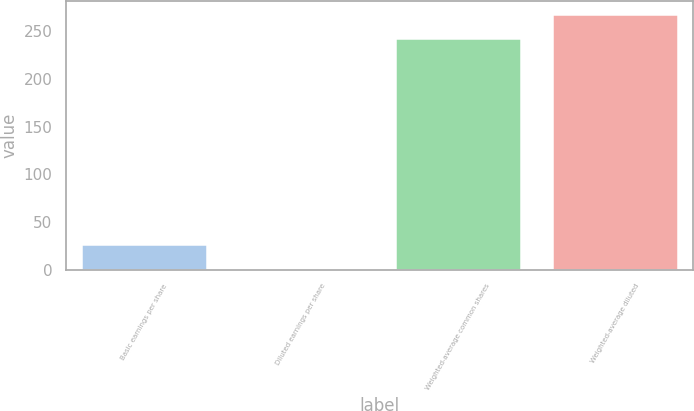Convert chart to OTSL. <chart><loc_0><loc_0><loc_500><loc_500><bar_chart><fcel>Basic earnings per share<fcel>Diluted earnings per share<fcel>Weighted-average common shares<fcel>Weighted-average diluted<nl><fcel>26.82<fcel>2.14<fcel>243.4<fcel>268.08<nl></chart> 